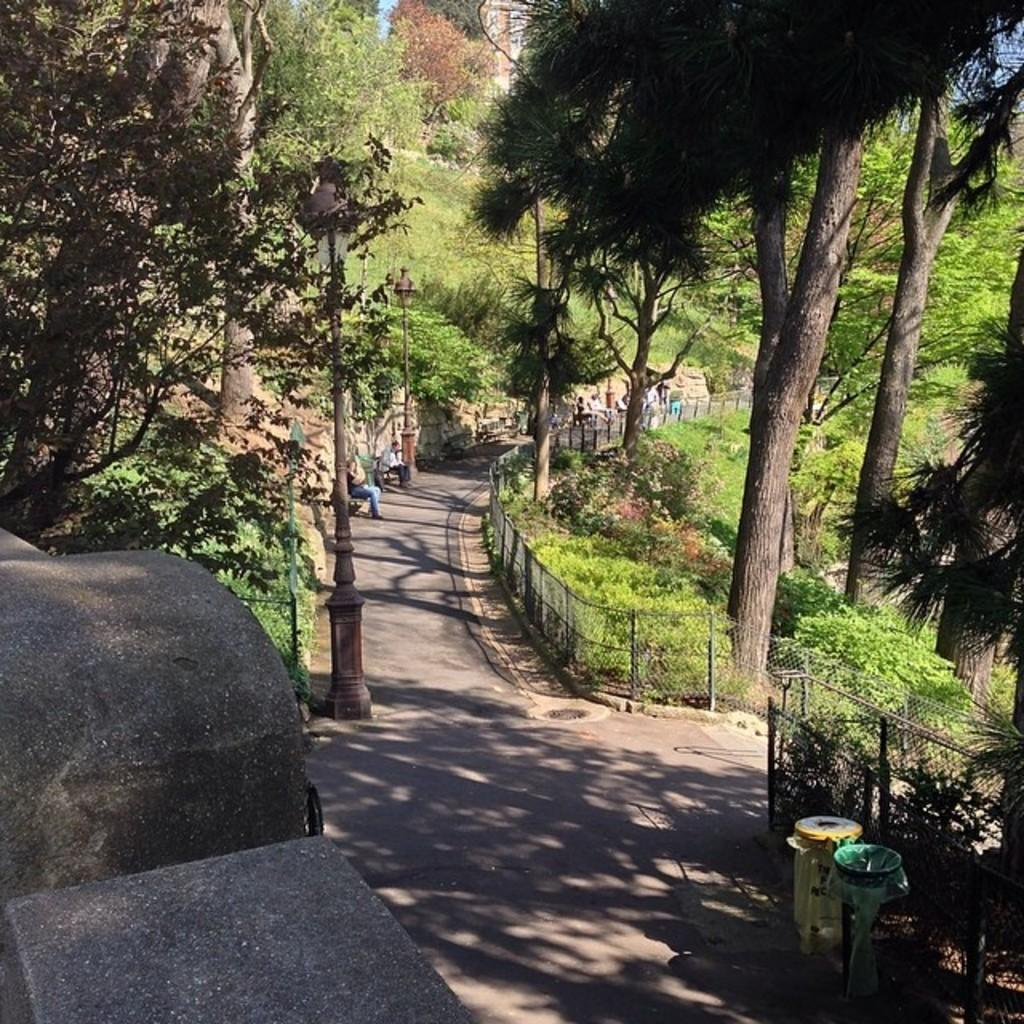What are the people in the image doing? The people in the image are sitting on benches. What can be seen in the background of the image? The sky is visible in the background of the image. What type of vegetation is present in the image? Trees, plants, and grass are visible in the image. What architectural feature can be seen in the image? There is a fence in the image. What is the primary mode of transportation visible in the image? There is a road visible in the image, but no specific mode of transportation is mentioned. What type of beam is being used by the carpenter in the image? There is no carpenter or beam present in the image. How many rolls of fabric can be seen in the image? There are no rolls of fabric present in the image. 